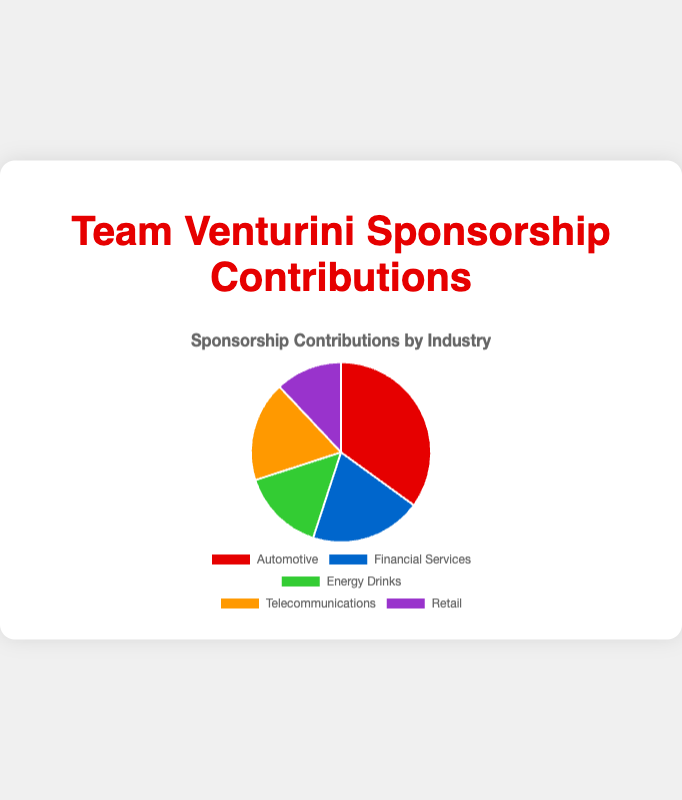What percentage of total sponsorship contributions comes from the Automotive and Retail industries combined? To find the combined percentage, add the percentages for the Automotive and Retail industries: 35% (Automotive) + 12% (Retail) = 47%.
Answer: 47% Which industry has the lowest sponsorship contribution and what is its percentage? By referring to the pie chart, the industry with the lowest percentage is Retail, at 12%.
Answer: Retail, 12% What is the difference in sponsorship contributions between the Automotive and Telecommunications industries? The Automotive industry contributes 35%, while Telecommunications contributes 18%. The difference is 35% - 18% = 17%.
Answer: 17% Which industry contributes more to Team Venturini: Energy Drinks or Financial Services, and by how much? Financial Services contributes 20%, while Energy Drinks contribute 15%. Financial Services contributes more by 20% - 15% = 5%.
Answer: Financial Services, 5% What color represents the Telecommunications industry in the pie chart? In the chart, the Telecommunications industry is represented by the orange color.
Answer: Orange Compare the combined contributions of Energy Drinks and Telecommunications with that of Automotive. Which is greater and by how much? Add the contributions of Energy Drinks (15%) and Telecommunications (18%) to get 33%. The Automotive industry contributes 35%. The difference is 35% - 33% = 2%, with Automotive contributing more.
Answer: Automotive, 2% What is the percentage difference between the Financial Services and Retail industries? Financial Services contribute 20%, and Retail contributes 12%. The difference is 20% - 12% = 8%.
Answer: 8% If the percentages of the Financial Services and Energy Drinks industries were swapped, what would be the new percentage contributions of each? Swapping the percentages would mean Financial Services would contribute 15%, and Energy Drinks would contribute 20%.
Answer: Financial Services: 15%, Energy Drinks: 20% How many major sponsors are listed for the Automotive and Energy Drinks industries combined? The Automotive industry has 3 major sponsors, and the Energy Drinks industry also has 3 major sponsors. Combined, they have 3 + 3 = 6 major sponsors.
Answer: 6 